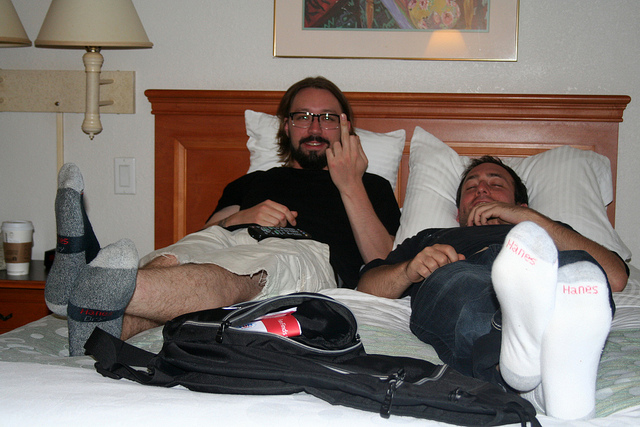Please transcribe the text in this image. Hanes 